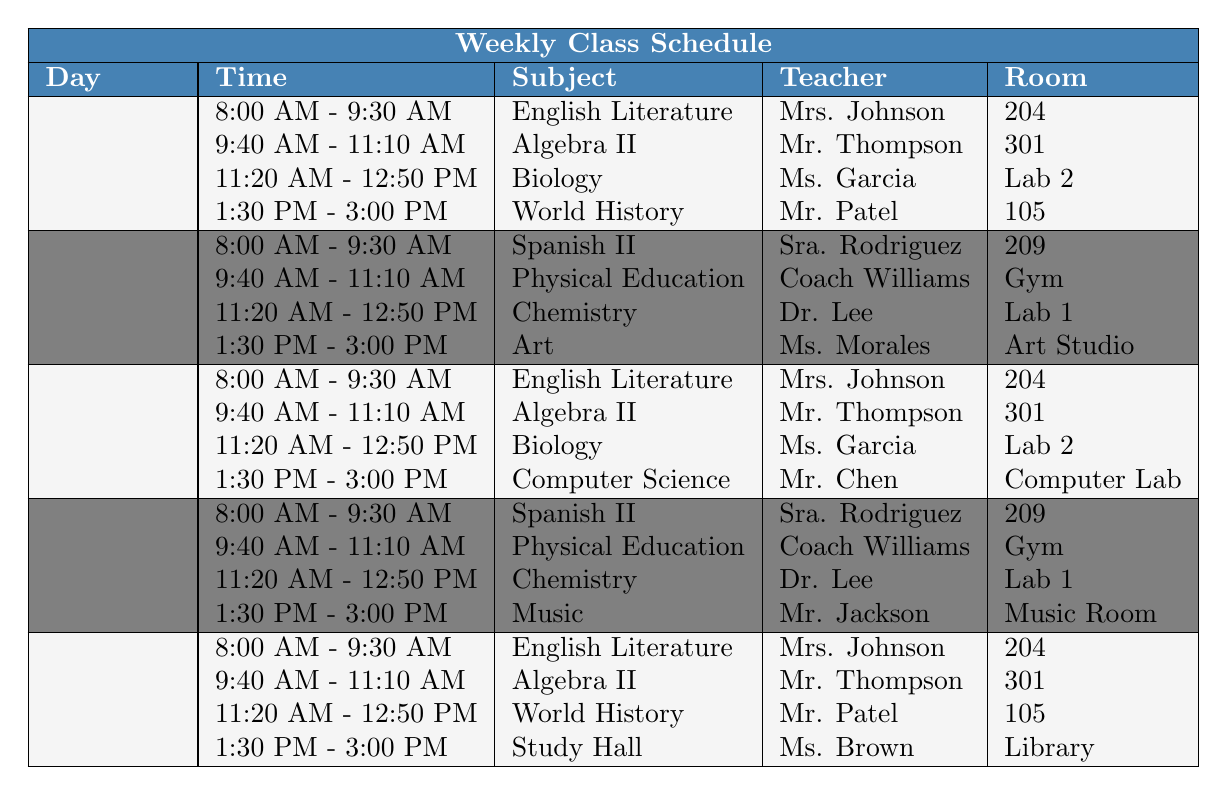What subject does the student have first on Monday? According to the table, the first period on Monday is from 8:00 AM to 9:30 AM, and the subject during that time is English Literature taught by Mrs. Johnson.
Answer: English Literature Who teaches Biology on Wednesday? The table indicates that Biology is taught by Ms. Garcia from 11:20 AM to 12:50 PM on Wednesday.
Answer: Ms. Garcia How many different subjects does the student have on Tuesday? The table shows that on Tuesday, there are four subjects listed: Spanish II, Physical Education, Chemistry, and Art. Thus, there are four different subjects.
Answer: 4 On which days does the student have English Literature? By examining the table, English Literature is scheduled on Monday, Wednesday, and Friday.
Answer: Monday, Wednesday, Friday What room does the student go to for Physical Education? The table specifies that Physical Education is held in the Gym on both Tuesday and Thursday.
Answer: Gym Does the student have a class on Friday from 1:30 PM to 3:00 PM? Yes, according to the table, from 1:30 PM to 3:00 PM on Friday, the student has Study Hall with Ms. Brown in the Library.
Answer: Yes What is the last class on Thursday? Looking at the table, the last period on Thursday is Music from 1:30 PM to 3:00 PM, taught by Mr. Jackson in the Music Room.
Answer: Music How many subjects are taught by Mr. Thompson? The table shows that Mr. Thompson teaches Algebra II on Monday, Wednesday, and Friday, which totals three classes.
Answer: 3 Find the difference in subjects between Monday and Tuesday. On Monday, there are four subjects (English Literature, Algebra II, Biology, World History), and on Tuesday, there are four subjects (Spanish II, Physical Education, Chemistry, Art). The difference is 4 - 4 = 0.
Answer: 0 Is Study Hall the only class scheduled in the Library? Yes, the table indicates that Study Hall is the only class that takes place in the Library on Friday from 1:30 PM to 3:00 PM.
Answer: Yes Which teacher teaches Chemistry? According to the table, Chemistry is taught by Dr. Lee on Tuesday and Thursday.
Answer: Dr. Lee On which day and time does the student have Computer Science? The table states that Computer Science is scheduled on Wednesday from 1:30 PM to 3:00 PM with Mr. Chen.
Answer: Wednesday, 1:30 PM - 3:00 PM 